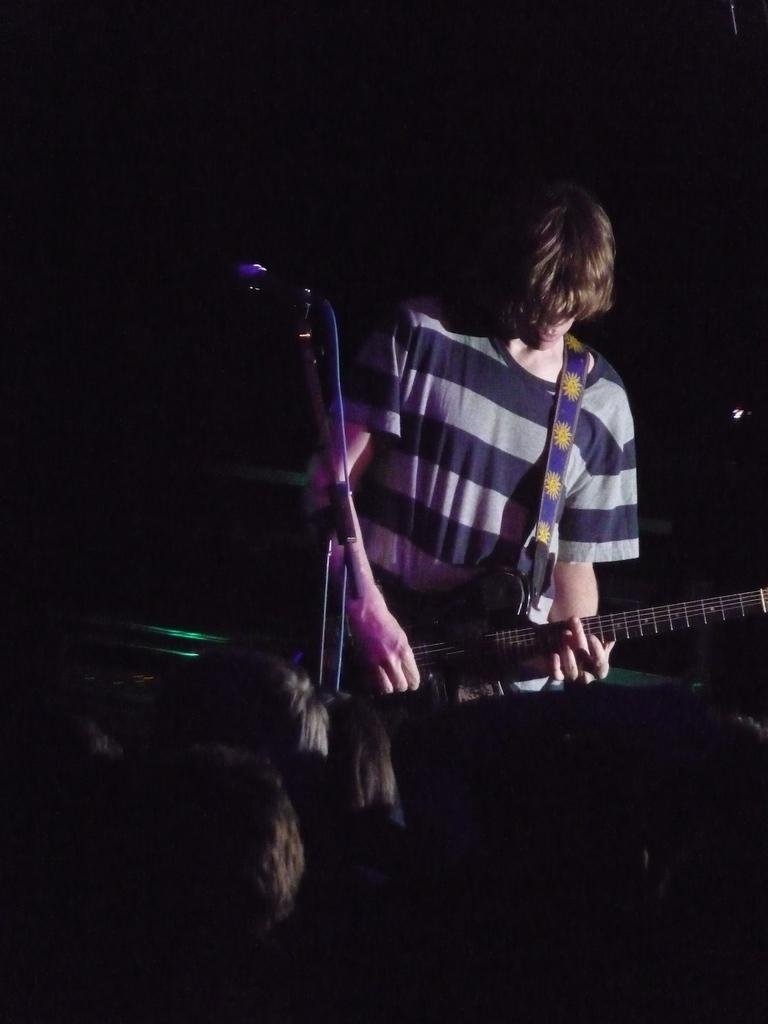Please provide a concise description of this image. This man is playing a guitar. This is a mic with holder. These are audience. 